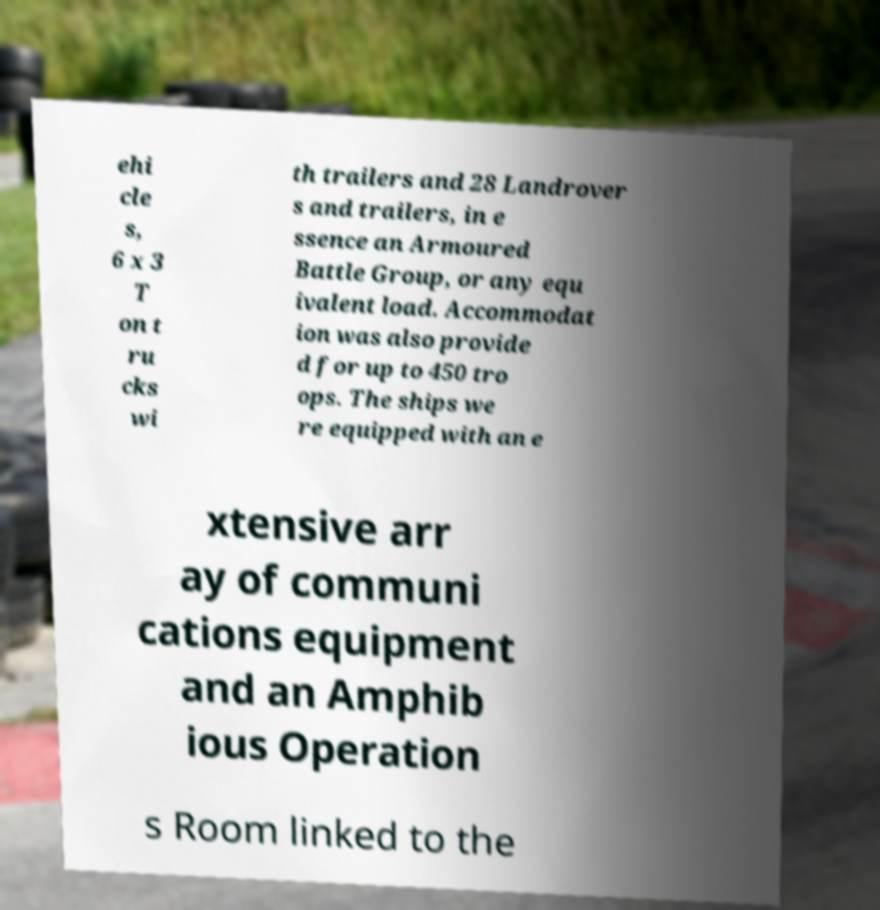There's text embedded in this image that I need extracted. Can you transcribe it verbatim? ehi cle s, 6 x 3 T on t ru cks wi th trailers and 28 Landrover s and trailers, in e ssence an Armoured Battle Group, or any equ ivalent load. Accommodat ion was also provide d for up to 450 tro ops. The ships we re equipped with an e xtensive arr ay of communi cations equipment and an Amphib ious Operation s Room linked to the 